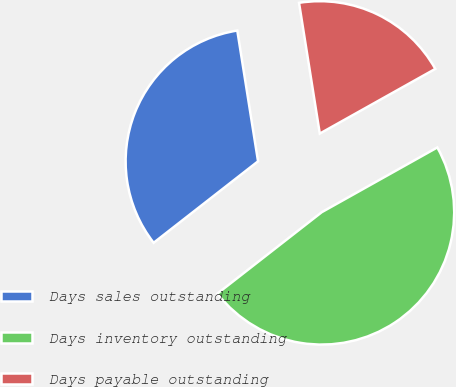Convert chart to OTSL. <chart><loc_0><loc_0><loc_500><loc_500><pie_chart><fcel>Days sales outstanding<fcel>Days inventory outstanding<fcel>Days payable outstanding<nl><fcel>33.04%<fcel>47.58%<fcel>19.38%<nl></chart> 